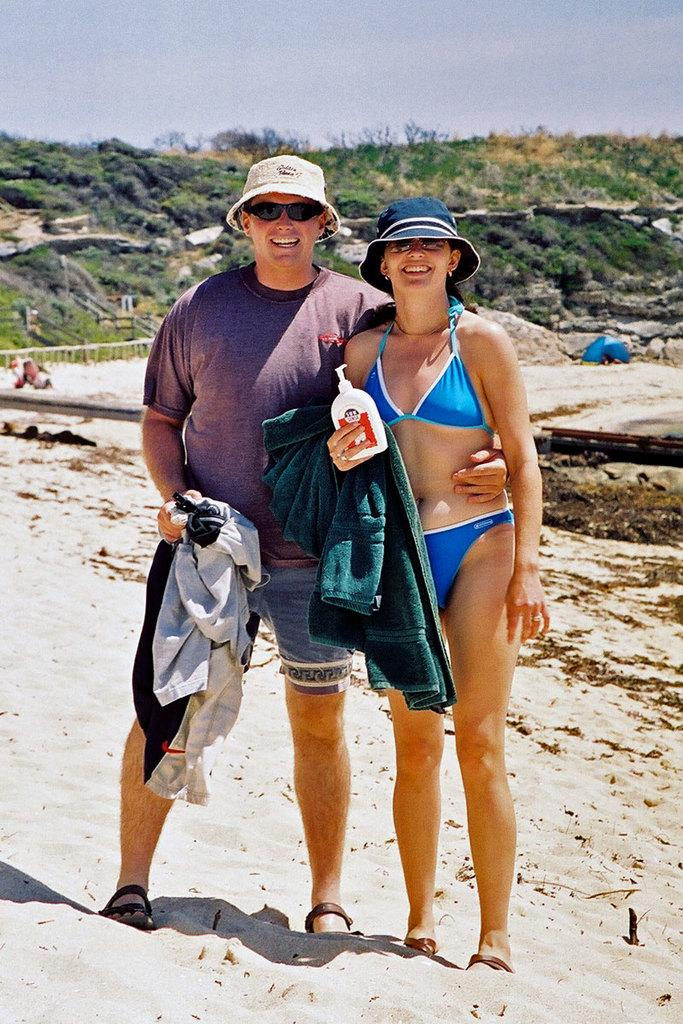How many people are present in the image? There are two people, a man and a woman, present in the image. What are the people in the image doing? Both the man and the woman are standing and smiling. What type of surface can be seen in the image? There is sand in the image. What is the color tint of the image? There is a blue color tint in the image. What type of vegetation is visible in the image? There are trees in the image. What is visible in the background of the image? The sky is visible in the background of the image. What type of ticket can be seen in the man's hand in the image? There is no ticket present in the image; the man's hands are not visible. What time of day is it in the image, based on the lighting and shadows? The provided facts do not give enough information to determine the time of day in the image. 